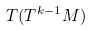Convert formula to latex. <formula><loc_0><loc_0><loc_500><loc_500>T ( T ^ { k - 1 } M )</formula> 